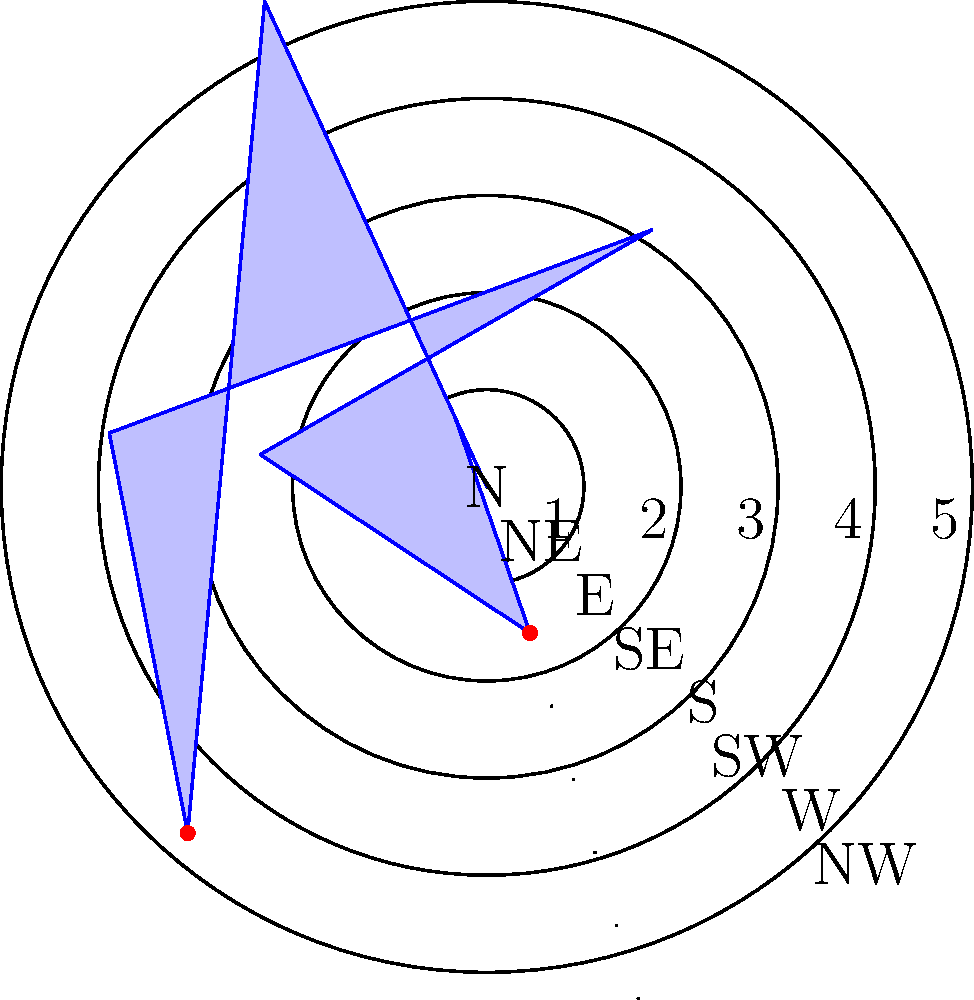The polar plot represents the distribution of different artistic styles across neighborhoods in the city. Each direction corresponds to a neighborhood, and the distance from the center indicates the prevalence of a particular style. Which two neighborhoods show an equal prevalence of the artistic style, and what is this prevalence value? To answer this question, we need to follow these steps:

1. Examine the polar plot carefully, noting that each radial direction represents a different neighborhood (N, NE, E, SE, S, SW, W, NW).

2. The distance from the center in each direction indicates the prevalence of the artistic style in that neighborhood, with values ranging from 0 to 5.

3. Look for two points on the plot that are equidistant from the center and on opposite sides.

4. We can see that there are two red dots on the plot, indicating points of interest.

5. These red dots are located in the East (E) and West (W) directions.

6. Both of these points are 4 units away from the center.

7. This means that the East and West neighborhoods have an equal prevalence of the artistic style, with a value of 4.

Therefore, the East (E) and West (W) neighborhoods show an equal prevalence of the artistic style, with a prevalence value of 4.
Answer: East and West; 4 